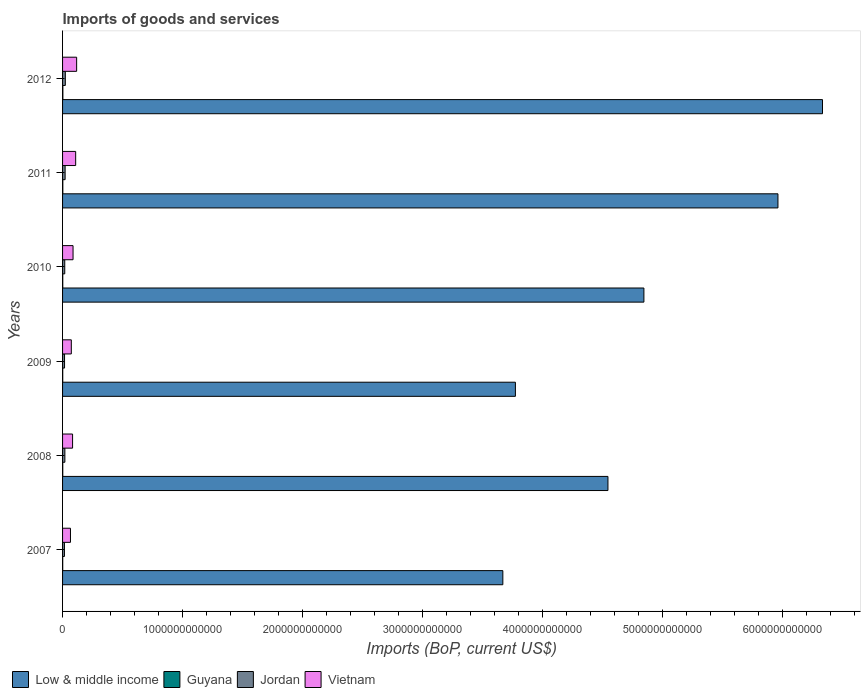How many groups of bars are there?
Your answer should be compact. 6. Are the number of bars per tick equal to the number of legend labels?
Provide a succinct answer. Yes. What is the label of the 3rd group of bars from the top?
Offer a very short reply. 2010. In how many cases, is the number of bars for a given year not equal to the number of legend labels?
Provide a succinct answer. 0. What is the amount spent on imports in Low & middle income in 2012?
Your answer should be compact. 6.33e+12. Across all years, what is the maximum amount spent on imports in Guyana?
Your answer should be compact. 2.52e+09. Across all years, what is the minimum amount spent on imports in Vietnam?
Provide a short and direct response. 6.58e+1. In which year was the amount spent on imports in Jordan maximum?
Provide a succinct answer. 2012. In which year was the amount spent on imports in Vietnam minimum?
Your answer should be very brief. 2007. What is the total amount spent on imports in Vietnam in the graph?
Keep it short and to the point. 5.36e+11. What is the difference between the amount spent on imports in Vietnam in 2008 and that in 2012?
Your response must be concise. -3.38e+1. What is the difference between the amount spent on imports in Jordan in 2010 and the amount spent on imports in Guyana in 2012?
Your answer should be very brief. 1.57e+1. What is the average amount spent on imports in Jordan per year?
Provide a short and direct response. 1.90e+1. In the year 2010, what is the difference between the amount spent on imports in Low & middle income and amount spent on imports in Vietnam?
Keep it short and to the point. 4.76e+12. What is the ratio of the amount spent on imports in Low & middle income in 2011 to that in 2012?
Your answer should be compact. 0.94. Is the difference between the amount spent on imports in Low & middle income in 2010 and 2012 greater than the difference between the amount spent on imports in Vietnam in 2010 and 2012?
Your response must be concise. No. What is the difference between the highest and the second highest amount spent on imports in Low & middle income?
Your answer should be compact. 3.71e+11. What is the difference between the highest and the lowest amount spent on imports in Vietnam?
Give a very brief answer. 5.14e+1. Is the sum of the amount spent on imports in Low & middle income in 2009 and 2012 greater than the maximum amount spent on imports in Vietnam across all years?
Provide a short and direct response. Yes. Is it the case that in every year, the sum of the amount spent on imports in Guyana and amount spent on imports in Low & middle income is greater than the sum of amount spent on imports in Jordan and amount spent on imports in Vietnam?
Provide a succinct answer. Yes. What does the 2nd bar from the top in 2009 represents?
Your answer should be compact. Jordan. What does the 4th bar from the bottom in 2011 represents?
Make the answer very short. Vietnam. Are all the bars in the graph horizontal?
Your answer should be very brief. Yes. How many years are there in the graph?
Ensure brevity in your answer.  6. What is the difference between two consecutive major ticks on the X-axis?
Ensure brevity in your answer.  1.00e+12. Does the graph contain any zero values?
Offer a terse response. No. Where does the legend appear in the graph?
Make the answer very short. Bottom left. How many legend labels are there?
Your response must be concise. 4. How are the legend labels stacked?
Give a very brief answer. Horizontal. What is the title of the graph?
Offer a terse response. Imports of goods and services. What is the label or title of the X-axis?
Your answer should be very brief. Imports (BoP, current US$). What is the Imports (BoP, current US$) in Low & middle income in 2007?
Provide a short and direct response. 3.67e+12. What is the Imports (BoP, current US$) in Guyana in 2007?
Provide a succinct answer. 1.26e+09. What is the Imports (BoP, current US$) of Jordan in 2007?
Your answer should be very brief. 1.57e+1. What is the Imports (BoP, current US$) of Vietnam in 2007?
Your answer should be compact. 6.58e+1. What is the Imports (BoP, current US$) of Low & middle income in 2008?
Provide a succinct answer. 4.54e+12. What is the Imports (BoP, current US$) of Guyana in 2008?
Give a very brief answer. 1.65e+09. What is the Imports (BoP, current US$) of Jordan in 2008?
Offer a terse response. 1.92e+1. What is the Imports (BoP, current US$) of Vietnam in 2008?
Keep it short and to the point. 8.34e+1. What is the Imports (BoP, current US$) of Low & middle income in 2009?
Ensure brevity in your answer.  3.77e+12. What is the Imports (BoP, current US$) of Guyana in 2009?
Provide a short and direct response. 1.45e+09. What is the Imports (BoP, current US$) in Jordan in 2009?
Offer a very short reply. 1.65e+1. What is the Imports (BoP, current US$) of Vietnam in 2009?
Keep it short and to the point. 7.29e+1. What is the Imports (BoP, current US$) of Low & middle income in 2010?
Ensure brevity in your answer.  4.84e+12. What is the Imports (BoP, current US$) in Guyana in 2010?
Your answer should be compact. 1.66e+09. What is the Imports (BoP, current US$) of Jordan in 2010?
Your answer should be very brief. 1.82e+1. What is the Imports (BoP, current US$) of Vietnam in 2010?
Your answer should be compact. 8.73e+1. What is the Imports (BoP, current US$) of Low & middle income in 2011?
Offer a terse response. 5.96e+12. What is the Imports (BoP, current US$) in Guyana in 2011?
Make the answer very short. 2.20e+09. What is the Imports (BoP, current US$) of Jordan in 2011?
Keep it short and to the point. 2.13e+1. What is the Imports (BoP, current US$) of Vietnam in 2011?
Make the answer very short. 1.09e+11. What is the Imports (BoP, current US$) in Low & middle income in 2012?
Make the answer very short. 6.33e+12. What is the Imports (BoP, current US$) of Guyana in 2012?
Make the answer very short. 2.52e+09. What is the Imports (BoP, current US$) in Jordan in 2012?
Offer a terse response. 2.30e+1. What is the Imports (BoP, current US$) in Vietnam in 2012?
Ensure brevity in your answer.  1.17e+11. Across all years, what is the maximum Imports (BoP, current US$) in Low & middle income?
Your answer should be compact. 6.33e+12. Across all years, what is the maximum Imports (BoP, current US$) in Guyana?
Provide a short and direct response. 2.52e+09. Across all years, what is the maximum Imports (BoP, current US$) of Jordan?
Provide a short and direct response. 2.30e+1. Across all years, what is the maximum Imports (BoP, current US$) in Vietnam?
Your response must be concise. 1.17e+11. Across all years, what is the minimum Imports (BoP, current US$) of Low & middle income?
Your response must be concise. 3.67e+12. Across all years, what is the minimum Imports (BoP, current US$) in Guyana?
Ensure brevity in your answer.  1.26e+09. Across all years, what is the minimum Imports (BoP, current US$) in Jordan?
Your response must be concise. 1.57e+1. Across all years, what is the minimum Imports (BoP, current US$) in Vietnam?
Your answer should be very brief. 6.58e+1. What is the total Imports (BoP, current US$) in Low & middle income in the graph?
Your response must be concise. 2.91e+13. What is the total Imports (BoP, current US$) in Guyana in the graph?
Keep it short and to the point. 1.07e+1. What is the total Imports (BoP, current US$) in Jordan in the graph?
Offer a very short reply. 1.14e+11. What is the total Imports (BoP, current US$) in Vietnam in the graph?
Provide a succinct answer. 5.36e+11. What is the difference between the Imports (BoP, current US$) of Low & middle income in 2007 and that in 2008?
Keep it short and to the point. -8.76e+11. What is the difference between the Imports (BoP, current US$) of Guyana in 2007 and that in 2008?
Offer a very short reply. -3.93e+08. What is the difference between the Imports (BoP, current US$) of Jordan in 2007 and that in 2008?
Your answer should be very brief. -3.53e+09. What is the difference between the Imports (BoP, current US$) in Vietnam in 2007 and that in 2008?
Make the answer very short. -1.76e+1. What is the difference between the Imports (BoP, current US$) of Low & middle income in 2007 and that in 2009?
Give a very brief answer. -1.05e+11. What is the difference between the Imports (BoP, current US$) of Guyana in 2007 and that in 2009?
Your response must be concise. -1.96e+08. What is the difference between the Imports (BoP, current US$) of Jordan in 2007 and that in 2009?
Your answer should be very brief. -7.58e+08. What is the difference between the Imports (BoP, current US$) in Vietnam in 2007 and that in 2009?
Your answer should be very brief. -7.11e+09. What is the difference between the Imports (BoP, current US$) of Low & middle income in 2007 and that in 2010?
Your response must be concise. -1.17e+12. What is the difference between the Imports (BoP, current US$) of Guyana in 2007 and that in 2010?
Make the answer very short. -4.02e+08. What is the difference between the Imports (BoP, current US$) of Jordan in 2007 and that in 2010?
Make the answer very short. -2.54e+09. What is the difference between the Imports (BoP, current US$) in Vietnam in 2007 and that in 2010?
Give a very brief answer. -2.15e+1. What is the difference between the Imports (BoP, current US$) in Low & middle income in 2007 and that in 2011?
Your answer should be compact. -2.29e+12. What is the difference between the Imports (BoP, current US$) in Guyana in 2007 and that in 2011?
Give a very brief answer. -9.49e+08. What is the difference between the Imports (BoP, current US$) in Jordan in 2007 and that in 2011?
Offer a very short reply. -5.60e+09. What is the difference between the Imports (BoP, current US$) of Vietnam in 2007 and that in 2011?
Make the answer very short. -4.34e+1. What is the difference between the Imports (BoP, current US$) of Low & middle income in 2007 and that in 2012?
Your response must be concise. -2.66e+12. What is the difference between the Imports (BoP, current US$) in Guyana in 2007 and that in 2012?
Your answer should be very brief. -1.27e+09. What is the difference between the Imports (BoP, current US$) in Jordan in 2007 and that in 2012?
Ensure brevity in your answer.  -7.27e+09. What is the difference between the Imports (BoP, current US$) in Vietnam in 2007 and that in 2012?
Make the answer very short. -5.14e+1. What is the difference between the Imports (BoP, current US$) in Low & middle income in 2008 and that in 2009?
Keep it short and to the point. 7.71e+11. What is the difference between the Imports (BoP, current US$) in Guyana in 2008 and that in 2009?
Your response must be concise. 1.97e+08. What is the difference between the Imports (BoP, current US$) in Jordan in 2008 and that in 2009?
Your answer should be compact. 2.77e+09. What is the difference between the Imports (BoP, current US$) in Vietnam in 2008 and that in 2009?
Offer a terse response. 1.05e+1. What is the difference between the Imports (BoP, current US$) of Low & middle income in 2008 and that in 2010?
Ensure brevity in your answer.  -2.99e+11. What is the difference between the Imports (BoP, current US$) of Guyana in 2008 and that in 2010?
Ensure brevity in your answer.  -8.76e+06. What is the difference between the Imports (BoP, current US$) of Jordan in 2008 and that in 2010?
Make the answer very short. 9.87e+08. What is the difference between the Imports (BoP, current US$) in Vietnam in 2008 and that in 2010?
Your answer should be compact. -3.87e+09. What is the difference between the Imports (BoP, current US$) of Low & middle income in 2008 and that in 2011?
Provide a short and direct response. -1.42e+12. What is the difference between the Imports (BoP, current US$) in Guyana in 2008 and that in 2011?
Offer a very short reply. -5.55e+08. What is the difference between the Imports (BoP, current US$) in Jordan in 2008 and that in 2011?
Provide a short and direct response. -2.07e+09. What is the difference between the Imports (BoP, current US$) in Vietnam in 2008 and that in 2011?
Provide a short and direct response. -2.58e+1. What is the difference between the Imports (BoP, current US$) of Low & middle income in 2008 and that in 2012?
Give a very brief answer. -1.79e+12. What is the difference between the Imports (BoP, current US$) in Guyana in 2008 and that in 2012?
Keep it short and to the point. -8.74e+08. What is the difference between the Imports (BoP, current US$) in Jordan in 2008 and that in 2012?
Your answer should be compact. -3.75e+09. What is the difference between the Imports (BoP, current US$) of Vietnam in 2008 and that in 2012?
Make the answer very short. -3.38e+1. What is the difference between the Imports (BoP, current US$) in Low & middle income in 2009 and that in 2010?
Offer a terse response. -1.07e+12. What is the difference between the Imports (BoP, current US$) in Guyana in 2009 and that in 2010?
Offer a very short reply. -2.06e+08. What is the difference between the Imports (BoP, current US$) of Jordan in 2009 and that in 2010?
Offer a very short reply. -1.78e+09. What is the difference between the Imports (BoP, current US$) of Vietnam in 2009 and that in 2010?
Your response must be concise. -1.44e+1. What is the difference between the Imports (BoP, current US$) of Low & middle income in 2009 and that in 2011?
Give a very brief answer. -2.19e+12. What is the difference between the Imports (BoP, current US$) in Guyana in 2009 and that in 2011?
Make the answer very short. -7.52e+08. What is the difference between the Imports (BoP, current US$) of Jordan in 2009 and that in 2011?
Provide a succinct answer. -4.84e+09. What is the difference between the Imports (BoP, current US$) in Vietnam in 2009 and that in 2011?
Your answer should be compact. -3.63e+1. What is the difference between the Imports (BoP, current US$) in Low & middle income in 2009 and that in 2012?
Give a very brief answer. -2.56e+12. What is the difference between the Imports (BoP, current US$) of Guyana in 2009 and that in 2012?
Make the answer very short. -1.07e+09. What is the difference between the Imports (BoP, current US$) of Jordan in 2009 and that in 2012?
Your answer should be compact. -6.52e+09. What is the difference between the Imports (BoP, current US$) in Vietnam in 2009 and that in 2012?
Make the answer very short. -4.43e+1. What is the difference between the Imports (BoP, current US$) of Low & middle income in 2010 and that in 2011?
Offer a very short reply. -1.12e+12. What is the difference between the Imports (BoP, current US$) of Guyana in 2010 and that in 2011?
Give a very brief answer. -5.47e+08. What is the difference between the Imports (BoP, current US$) of Jordan in 2010 and that in 2011?
Give a very brief answer. -3.06e+09. What is the difference between the Imports (BoP, current US$) in Vietnam in 2010 and that in 2011?
Keep it short and to the point. -2.19e+1. What is the difference between the Imports (BoP, current US$) in Low & middle income in 2010 and that in 2012?
Provide a succinct answer. -1.49e+12. What is the difference between the Imports (BoP, current US$) in Guyana in 2010 and that in 2012?
Your answer should be compact. -8.66e+08. What is the difference between the Imports (BoP, current US$) of Jordan in 2010 and that in 2012?
Offer a very short reply. -4.73e+09. What is the difference between the Imports (BoP, current US$) of Vietnam in 2010 and that in 2012?
Provide a short and direct response. -2.99e+1. What is the difference between the Imports (BoP, current US$) in Low & middle income in 2011 and that in 2012?
Make the answer very short. -3.71e+11. What is the difference between the Imports (BoP, current US$) in Guyana in 2011 and that in 2012?
Give a very brief answer. -3.19e+08. What is the difference between the Imports (BoP, current US$) of Jordan in 2011 and that in 2012?
Your response must be concise. -1.67e+09. What is the difference between the Imports (BoP, current US$) in Vietnam in 2011 and that in 2012?
Your answer should be very brief. -7.99e+09. What is the difference between the Imports (BoP, current US$) in Low & middle income in 2007 and the Imports (BoP, current US$) in Guyana in 2008?
Offer a very short reply. 3.67e+12. What is the difference between the Imports (BoP, current US$) in Low & middle income in 2007 and the Imports (BoP, current US$) in Jordan in 2008?
Provide a short and direct response. 3.65e+12. What is the difference between the Imports (BoP, current US$) of Low & middle income in 2007 and the Imports (BoP, current US$) of Vietnam in 2008?
Ensure brevity in your answer.  3.58e+12. What is the difference between the Imports (BoP, current US$) in Guyana in 2007 and the Imports (BoP, current US$) in Jordan in 2008?
Your response must be concise. -1.80e+1. What is the difference between the Imports (BoP, current US$) of Guyana in 2007 and the Imports (BoP, current US$) of Vietnam in 2008?
Your answer should be compact. -8.22e+1. What is the difference between the Imports (BoP, current US$) in Jordan in 2007 and the Imports (BoP, current US$) in Vietnam in 2008?
Offer a very short reply. -6.77e+1. What is the difference between the Imports (BoP, current US$) of Low & middle income in 2007 and the Imports (BoP, current US$) of Guyana in 2009?
Your response must be concise. 3.67e+12. What is the difference between the Imports (BoP, current US$) of Low & middle income in 2007 and the Imports (BoP, current US$) of Jordan in 2009?
Provide a succinct answer. 3.65e+12. What is the difference between the Imports (BoP, current US$) in Low & middle income in 2007 and the Imports (BoP, current US$) in Vietnam in 2009?
Keep it short and to the point. 3.59e+12. What is the difference between the Imports (BoP, current US$) of Guyana in 2007 and the Imports (BoP, current US$) of Jordan in 2009?
Make the answer very short. -1.52e+1. What is the difference between the Imports (BoP, current US$) in Guyana in 2007 and the Imports (BoP, current US$) in Vietnam in 2009?
Your answer should be compact. -7.16e+1. What is the difference between the Imports (BoP, current US$) of Jordan in 2007 and the Imports (BoP, current US$) of Vietnam in 2009?
Provide a short and direct response. -5.72e+1. What is the difference between the Imports (BoP, current US$) in Low & middle income in 2007 and the Imports (BoP, current US$) in Guyana in 2010?
Your response must be concise. 3.67e+12. What is the difference between the Imports (BoP, current US$) in Low & middle income in 2007 and the Imports (BoP, current US$) in Jordan in 2010?
Your answer should be compact. 3.65e+12. What is the difference between the Imports (BoP, current US$) of Low & middle income in 2007 and the Imports (BoP, current US$) of Vietnam in 2010?
Your response must be concise. 3.58e+12. What is the difference between the Imports (BoP, current US$) of Guyana in 2007 and the Imports (BoP, current US$) of Jordan in 2010?
Your answer should be very brief. -1.70e+1. What is the difference between the Imports (BoP, current US$) of Guyana in 2007 and the Imports (BoP, current US$) of Vietnam in 2010?
Give a very brief answer. -8.60e+1. What is the difference between the Imports (BoP, current US$) in Jordan in 2007 and the Imports (BoP, current US$) in Vietnam in 2010?
Make the answer very short. -7.16e+1. What is the difference between the Imports (BoP, current US$) of Low & middle income in 2007 and the Imports (BoP, current US$) of Guyana in 2011?
Ensure brevity in your answer.  3.67e+12. What is the difference between the Imports (BoP, current US$) in Low & middle income in 2007 and the Imports (BoP, current US$) in Jordan in 2011?
Provide a short and direct response. 3.65e+12. What is the difference between the Imports (BoP, current US$) in Low & middle income in 2007 and the Imports (BoP, current US$) in Vietnam in 2011?
Provide a succinct answer. 3.56e+12. What is the difference between the Imports (BoP, current US$) in Guyana in 2007 and the Imports (BoP, current US$) in Jordan in 2011?
Provide a succinct answer. -2.00e+1. What is the difference between the Imports (BoP, current US$) in Guyana in 2007 and the Imports (BoP, current US$) in Vietnam in 2011?
Ensure brevity in your answer.  -1.08e+11. What is the difference between the Imports (BoP, current US$) of Jordan in 2007 and the Imports (BoP, current US$) of Vietnam in 2011?
Give a very brief answer. -9.35e+1. What is the difference between the Imports (BoP, current US$) of Low & middle income in 2007 and the Imports (BoP, current US$) of Guyana in 2012?
Your answer should be compact. 3.66e+12. What is the difference between the Imports (BoP, current US$) in Low & middle income in 2007 and the Imports (BoP, current US$) in Jordan in 2012?
Your answer should be compact. 3.64e+12. What is the difference between the Imports (BoP, current US$) in Low & middle income in 2007 and the Imports (BoP, current US$) in Vietnam in 2012?
Your answer should be compact. 3.55e+12. What is the difference between the Imports (BoP, current US$) in Guyana in 2007 and the Imports (BoP, current US$) in Jordan in 2012?
Offer a very short reply. -2.17e+1. What is the difference between the Imports (BoP, current US$) of Guyana in 2007 and the Imports (BoP, current US$) of Vietnam in 2012?
Your response must be concise. -1.16e+11. What is the difference between the Imports (BoP, current US$) in Jordan in 2007 and the Imports (BoP, current US$) in Vietnam in 2012?
Offer a terse response. -1.02e+11. What is the difference between the Imports (BoP, current US$) of Low & middle income in 2008 and the Imports (BoP, current US$) of Guyana in 2009?
Provide a short and direct response. 4.54e+12. What is the difference between the Imports (BoP, current US$) in Low & middle income in 2008 and the Imports (BoP, current US$) in Jordan in 2009?
Offer a terse response. 4.53e+12. What is the difference between the Imports (BoP, current US$) of Low & middle income in 2008 and the Imports (BoP, current US$) of Vietnam in 2009?
Your answer should be very brief. 4.47e+12. What is the difference between the Imports (BoP, current US$) of Guyana in 2008 and the Imports (BoP, current US$) of Jordan in 2009?
Offer a very short reply. -1.48e+1. What is the difference between the Imports (BoP, current US$) in Guyana in 2008 and the Imports (BoP, current US$) in Vietnam in 2009?
Offer a terse response. -7.12e+1. What is the difference between the Imports (BoP, current US$) of Jordan in 2008 and the Imports (BoP, current US$) of Vietnam in 2009?
Your response must be concise. -5.37e+1. What is the difference between the Imports (BoP, current US$) in Low & middle income in 2008 and the Imports (BoP, current US$) in Guyana in 2010?
Your response must be concise. 4.54e+12. What is the difference between the Imports (BoP, current US$) in Low & middle income in 2008 and the Imports (BoP, current US$) in Jordan in 2010?
Ensure brevity in your answer.  4.52e+12. What is the difference between the Imports (BoP, current US$) in Low & middle income in 2008 and the Imports (BoP, current US$) in Vietnam in 2010?
Offer a very short reply. 4.46e+12. What is the difference between the Imports (BoP, current US$) in Guyana in 2008 and the Imports (BoP, current US$) in Jordan in 2010?
Ensure brevity in your answer.  -1.66e+1. What is the difference between the Imports (BoP, current US$) in Guyana in 2008 and the Imports (BoP, current US$) in Vietnam in 2010?
Your response must be concise. -8.56e+1. What is the difference between the Imports (BoP, current US$) in Jordan in 2008 and the Imports (BoP, current US$) in Vietnam in 2010?
Give a very brief answer. -6.81e+1. What is the difference between the Imports (BoP, current US$) in Low & middle income in 2008 and the Imports (BoP, current US$) in Guyana in 2011?
Offer a terse response. 4.54e+12. What is the difference between the Imports (BoP, current US$) of Low & middle income in 2008 and the Imports (BoP, current US$) of Jordan in 2011?
Provide a succinct answer. 4.52e+12. What is the difference between the Imports (BoP, current US$) in Low & middle income in 2008 and the Imports (BoP, current US$) in Vietnam in 2011?
Your answer should be very brief. 4.43e+12. What is the difference between the Imports (BoP, current US$) in Guyana in 2008 and the Imports (BoP, current US$) in Jordan in 2011?
Offer a very short reply. -1.97e+1. What is the difference between the Imports (BoP, current US$) of Guyana in 2008 and the Imports (BoP, current US$) of Vietnam in 2011?
Offer a terse response. -1.08e+11. What is the difference between the Imports (BoP, current US$) of Jordan in 2008 and the Imports (BoP, current US$) of Vietnam in 2011?
Make the answer very short. -9.00e+1. What is the difference between the Imports (BoP, current US$) of Low & middle income in 2008 and the Imports (BoP, current US$) of Guyana in 2012?
Your answer should be very brief. 4.54e+12. What is the difference between the Imports (BoP, current US$) in Low & middle income in 2008 and the Imports (BoP, current US$) in Jordan in 2012?
Keep it short and to the point. 4.52e+12. What is the difference between the Imports (BoP, current US$) in Low & middle income in 2008 and the Imports (BoP, current US$) in Vietnam in 2012?
Provide a short and direct response. 4.43e+12. What is the difference between the Imports (BoP, current US$) in Guyana in 2008 and the Imports (BoP, current US$) in Jordan in 2012?
Provide a succinct answer. -2.13e+1. What is the difference between the Imports (BoP, current US$) of Guyana in 2008 and the Imports (BoP, current US$) of Vietnam in 2012?
Provide a short and direct response. -1.16e+11. What is the difference between the Imports (BoP, current US$) of Jordan in 2008 and the Imports (BoP, current US$) of Vietnam in 2012?
Offer a terse response. -9.80e+1. What is the difference between the Imports (BoP, current US$) in Low & middle income in 2009 and the Imports (BoP, current US$) in Guyana in 2010?
Your response must be concise. 3.77e+12. What is the difference between the Imports (BoP, current US$) of Low & middle income in 2009 and the Imports (BoP, current US$) of Jordan in 2010?
Give a very brief answer. 3.75e+12. What is the difference between the Imports (BoP, current US$) in Low & middle income in 2009 and the Imports (BoP, current US$) in Vietnam in 2010?
Provide a short and direct response. 3.68e+12. What is the difference between the Imports (BoP, current US$) in Guyana in 2009 and the Imports (BoP, current US$) in Jordan in 2010?
Provide a short and direct response. -1.68e+1. What is the difference between the Imports (BoP, current US$) of Guyana in 2009 and the Imports (BoP, current US$) of Vietnam in 2010?
Offer a very short reply. -8.58e+1. What is the difference between the Imports (BoP, current US$) in Jordan in 2009 and the Imports (BoP, current US$) in Vietnam in 2010?
Offer a very short reply. -7.08e+1. What is the difference between the Imports (BoP, current US$) of Low & middle income in 2009 and the Imports (BoP, current US$) of Guyana in 2011?
Your response must be concise. 3.77e+12. What is the difference between the Imports (BoP, current US$) of Low & middle income in 2009 and the Imports (BoP, current US$) of Jordan in 2011?
Offer a terse response. 3.75e+12. What is the difference between the Imports (BoP, current US$) in Low & middle income in 2009 and the Imports (BoP, current US$) in Vietnam in 2011?
Provide a short and direct response. 3.66e+12. What is the difference between the Imports (BoP, current US$) of Guyana in 2009 and the Imports (BoP, current US$) of Jordan in 2011?
Your answer should be compact. -1.98e+1. What is the difference between the Imports (BoP, current US$) in Guyana in 2009 and the Imports (BoP, current US$) in Vietnam in 2011?
Give a very brief answer. -1.08e+11. What is the difference between the Imports (BoP, current US$) in Jordan in 2009 and the Imports (BoP, current US$) in Vietnam in 2011?
Offer a very short reply. -9.28e+1. What is the difference between the Imports (BoP, current US$) in Low & middle income in 2009 and the Imports (BoP, current US$) in Guyana in 2012?
Offer a very short reply. 3.77e+12. What is the difference between the Imports (BoP, current US$) of Low & middle income in 2009 and the Imports (BoP, current US$) of Jordan in 2012?
Your answer should be very brief. 3.75e+12. What is the difference between the Imports (BoP, current US$) in Low & middle income in 2009 and the Imports (BoP, current US$) in Vietnam in 2012?
Offer a very short reply. 3.65e+12. What is the difference between the Imports (BoP, current US$) in Guyana in 2009 and the Imports (BoP, current US$) in Jordan in 2012?
Your answer should be compact. -2.15e+1. What is the difference between the Imports (BoP, current US$) of Guyana in 2009 and the Imports (BoP, current US$) of Vietnam in 2012?
Offer a very short reply. -1.16e+11. What is the difference between the Imports (BoP, current US$) in Jordan in 2009 and the Imports (BoP, current US$) in Vietnam in 2012?
Provide a short and direct response. -1.01e+11. What is the difference between the Imports (BoP, current US$) of Low & middle income in 2010 and the Imports (BoP, current US$) of Guyana in 2011?
Provide a succinct answer. 4.84e+12. What is the difference between the Imports (BoP, current US$) in Low & middle income in 2010 and the Imports (BoP, current US$) in Jordan in 2011?
Provide a succinct answer. 4.82e+12. What is the difference between the Imports (BoP, current US$) of Low & middle income in 2010 and the Imports (BoP, current US$) of Vietnam in 2011?
Ensure brevity in your answer.  4.73e+12. What is the difference between the Imports (BoP, current US$) in Guyana in 2010 and the Imports (BoP, current US$) in Jordan in 2011?
Keep it short and to the point. -1.96e+1. What is the difference between the Imports (BoP, current US$) in Guyana in 2010 and the Imports (BoP, current US$) in Vietnam in 2011?
Ensure brevity in your answer.  -1.08e+11. What is the difference between the Imports (BoP, current US$) in Jordan in 2010 and the Imports (BoP, current US$) in Vietnam in 2011?
Your answer should be very brief. -9.10e+1. What is the difference between the Imports (BoP, current US$) in Low & middle income in 2010 and the Imports (BoP, current US$) in Guyana in 2012?
Provide a short and direct response. 4.84e+12. What is the difference between the Imports (BoP, current US$) of Low & middle income in 2010 and the Imports (BoP, current US$) of Jordan in 2012?
Your answer should be very brief. 4.82e+12. What is the difference between the Imports (BoP, current US$) in Low & middle income in 2010 and the Imports (BoP, current US$) in Vietnam in 2012?
Make the answer very short. 4.73e+12. What is the difference between the Imports (BoP, current US$) of Guyana in 2010 and the Imports (BoP, current US$) of Jordan in 2012?
Provide a short and direct response. -2.13e+1. What is the difference between the Imports (BoP, current US$) of Guyana in 2010 and the Imports (BoP, current US$) of Vietnam in 2012?
Offer a terse response. -1.16e+11. What is the difference between the Imports (BoP, current US$) of Jordan in 2010 and the Imports (BoP, current US$) of Vietnam in 2012?
Provide a succinct answer. -9.90e+1. What is the difference between the Imports (BoP, current US$) in Low & middle income in 2011 and the Imports (BoP, current US$) in Guyana in 2012?
Give a very brief answer. 5.96e+12. What is the difference between the Imports (BoP, current US$) of Low & middle income in 2011 and the Imports (BoP, current US$) of Jordan in 2012?
Make the answer very short. 5.94e+12. What is the difference between the Imports (BoP, current US$) in Low & middle income in 2011 and the Imports (BoP, current US$) in Vietnam in 2012?
Your answer should be very brief. 5.84e+12. What is the difference between the Imports (BoP, current US$) in Guyana in 2011 and the Imports (BoP, current US$) in Jordan in 2012?
Your response must be concise. -2.08e+1. What is the difference between the Imports (BoP, current US$) of Guyana in 2011 and the Imports (BoP, current US$) of Vietnam in 2012?
Make the answer very short. -1.15e+11. What is the difference between the Imports (BoP, current US$) of Jordan in 2011 and the Imports (BoP, current US$) of Vietnam in 2012?
Keep it short and to the point. -9.59e+1. What is the average Imports (BoP, current US$) of Low & middle income per year?
Keep it short and to the point. 4.85e+12. What is the average Imports (BoP, current US$) of Guyana per year?
Your answer should be compact. 1.79e+09. What is the average Imports (BoP, current US$) of Jordan per year?
Make the answer very short. 1.90e+1. What is the average Imports (BoP, current US$) of Vietnam per year?
Your answer should be compact. 8.93e+1. In the year 2007, what is the difference between the Imports (BoP, current US$) of Low & middle income and Imports (BoP, current US$) of Guyana?
Ensure brevity in your answer.  3.67e+12. In the year 2007, what is the difference between the Imports (BoP, current US$) in Low & middle income and Imports (BoP, current US$) in Jordan?
Offer a very short reply. 3.65e+12. In the year 2007, what is the difference between the Imports (BoP, current US$) of Low & middle income and Imports (BoP, current US$) of Vietnam?
Give a very brief answer. 3.60e+12. In the year 2007, what is the difference between the Imports (BoP, current US$) in Guyana and Imports (BoP, current US$) in Jordan?
Your answer should be very brief. -1.44e+1. In the year 2007, what is the difference between the Imports (BoP, current US$) of Guyana and Imports (BoP, current US$) of Vietnam?
Provide a succinct answer. -6.45e+1. In the year 2007, what is the difference between the Imports (BoP, current US$) in Jordan and Imports (BoP, current US$) in Vietnam?
Ensure brevity in your answer.  -5.01e+1. In the year 2008, what is the difference between the Imports (BoP, current US$) of Low & middle income and Imports (BoP, current US$) of Guyana?
Provide a succinct answer. 4.54e+12. In the year 2008, what is the difference between the Imports (BoP, current US$) in Low & middle income and Imports (BoP, current US$) in Jordan?
Your answer should be compact. 4.52e+12. In the year 2008, what is the difference between the Imports (BoP, current US$) in Low & middle income and Imports (BoP, current US$) in Vietnam?
Make the answer very short. 4.46e+12. In the year 2008, what is the difference between the Imports (BoP, current US$) in Guyana and Imports (BoP, current US$) in Jordan?
Your response must be concise. -1.76e+1. In the year 2008, what is the difference between the Imports (BoP, current US$) in Guyana and Imports (BoP, current US$) in Vietnam?
Make the answer very short. -8.18e+1. In the year 2008, what is the difference between the Imports (BoP, current US$) of Jordan and Imports (BoP, current US$) of Vietnam?
Give a very brief answer. -6.42e+1. In the year 2009, what is the difference between the Imports (BoP, current US$) in Low & middle income and Imports (BoP, current US$) in Guyana?
Offer a terse response. 3.77e+12. In the year 2009, what is the difference between the Imports (BoP, current US$) in Low & middle income and Imports (BoP, current US$) in Jordan?
Give a very brief answer. 3.76e+12. In the year 2009, what is the difference between the Imports (BoP, current US$) of Low & middle income and Imports (BoP, current US$) of Vietnam?
Keep it short and to the point. 3.70e+12. In the year 2009, what is the difference between the Imports (BoP, current US$) in Guyana and Imports (BoP, current US$) in Jordan?
Keep it short and to the point. -1.50e+1. In the year 2009, what is the difference between the Imports (BoP, current US$) of Guyana and Imports (BoP, current US$) of Vietnam?
Provide a succinct answer. -7.14e+1. In the year 2009, what is the difference between the Imports (BoP, current US$) in Jordan and Imports (BoP, current US$) in Vietnam?
Provide a succinct answer. -5.64e+1. In the year 2010, what is the difference between the Imports (BoP, current US$) of Low & middle income and Imports (BoP, current US$) of Guyana?
Offer a very short reply. 4.84e+12. In the year 2010, what is the difference between the Imports (BoP, current US$) of Low & middle income and Imports (BoP, current US$) of Jordan?
Your answer should be compact. 4.82e+12. In the year 2010, what is the difference between the Imports (BoP, current US$) in Low & middle income and Imports (BoP, current US$) in Vietnam?
Your answer should be very brief. 4.76e+12. In the year 2010, what is the difference between the Imports (BoP, current US$) of Guyana and Imports (BoP, current US$) of Jordan?
Ensure brevity in your answer.  -1.66e+1. In the year 2010, what is the difference between the Imports (BoP, current US$) of Guyana and Imports (BoP, current US$) of Vietnam?
Offer a very short reply. -8.56e+1. In the year 2010, what is the difference between the Imports (BoP, current US$) of Jordan and Imports (BoP, current US$) of Vietnam?
Your answer should be very brief. -6.91e+1. In the year 2011, what is the difference between the Imports (BoP, current US$) in Low & middle income and Imports (BoP, current US$) in Guyana?
Provide a short and direct response. 5.96e+12. In the year 2011, what is the difference between the Imports (BoP, current US$) of Low & middle income and Imports (BoP, current US$) of Jordan?
Provide a short and direct response. 5.94e+12. In the year 2011, what is the difference between the Imports (BoP, current US$) of Low & middle income and Imports (BoP, current US$) of Vietnam?
Your response must be concise. 5.85e+12. In the year 2011, what is the difference between the Imports (BoP, current US$) of Guyana and Imports (BoP, current US$) of Jordan?
Your answer should be very brief. -1.91e+1. In the year 2011, what is the difference between the Imports (BoP, current US$) of Guyana and Imports (BoP, current US$) of Vietnam?
Your response must be concise. -1.07e+11. In the year 2011, what is the difference between the Imports (BoP, current US$) in Jordan and Imports (BoP, current US$) in Vietnam?
Your response must be concise. -8.79e+1. In the year 2012, what is the difference between the Imports (BoP, current US$) of Low & middle income and Imports (BoP, current US$) of Guyana?
Offer a terse response. 6.33e+12. In the year 2012, what is the difference between the Imports (BoP, current US$) of Low & middle income and Imports (BoP, current US$) of Jordan?
Your answer should be very brief. 6.31e+12. In the year 2012, what is the difference between the Imports (BoP, current US$) in Low & middle income and Imports (BoP, current US$) in Vietnam?
Give a very brief answer. 6.21e+12. In the year 2012, what is the difference between the Imports (BoP, current US$) of Guyana and Imports (BoP, current US$) of Jordan?
Make the answer very short. -2.05e+1. In the year 2012, what is the difference between the Imports (BoP, current US$) in Guyana and Imports (BoP, current US$) in Vietnam?
Offer a very short reply. -1.15e+11. In the year 2012, what is the difference between the Imports (BoP, current US$) in Jordan and Imports (BoP, current US$) in Vietnam?
Offer a terse response. -9.42e+1. What is the ratio of the Imports (BoP, current US$) of Low & middle income in 2007 to that in 2008?
Provide a succinct answer. 0.81. What is the ratio of the Imports (BoP, current US$) of Guyana in 2007 to that in 2008?
Keep it short and to the point. 0.76. What is the ratio of the Imports (BoP, current US$) in Jordan in 2007 to that in 2008?
Keep it short and to the point. 0.82. What is the ratio of the Imports (BoP, current US$) in Vietnam in 2007 to that in 2008?
Offer a terse response. 0.79. What is the ratio of the Imports (BoP, current US$) of Low & middle income in 2007 to that in 2009?
Your answer should be compact. 0.97. What is the ratio of the Imports (BoP, current US$) of Guyana in 2007 to that in 2009?
Keep it short and to the point. 0.86. What is the ratio of the Imports (BoP, current US$) of Jordan in 2007 to that in 2009?
Keep it short and to the point. 0.95. What is the ratio of the Imports (BoP, current US$) in Vietnam in 2007 to that in 2009?
Keep it short and to the point. 0.9. What is the ratio of the Imports (BoP, current US$) of Low & middle income in 2007 to that in 2010?
Ensure brevity in your answer.  0.76. What is the ratio of the Imports (BoP, current US$) of Guyana in 2007 to that in 2010?
Give a very brief answer. 0.76. What is the ratio of the Imports (BoP, current US$) of Jordan in 2007 to that in 2010?
Ensure brevity in your answer.  0.86. What is the ratio of the Imports (BoP, current US$) in Vietnam in 2007 to that in 2010?
Keep it short and to the point. 0.75. What is the ratio of the Imports (BoP, current US$) in Low & middle income in 2007 to that in 2011?
Provide a short and direct response. 0.62. What is the ratio of the Imports (BoP, current US$) of Guyana in 2007 to that in 2011?
Offer a very short reply. 0.57. What is the ratio of the Imports (BoP, current US$) in Jordan in 2007 to that in 2011?
Make the answer very short. 0.74. What is the ratio of the Imports (BoP, current US$) in Vietnam in 2007 to that in 2011?
Provide a succinct answer. 0.6. What is the ratio of the Imports (BoP, current US$) of Low & middle income in 2007 to that in 2012?
Keep it short and to the point. 0.58. What is the ratio of the Imports (BoP, current US$) of Guyana in 2007 to that in 2012?
Offer a terse response. 0.5. What is the ratio of the Imports (BoP, current US$) of Jordan in 2007 to that in 2012?
Your answer should be very brief. 0.68. What is the ratio of the Imports (BoP, current US$) in Vietnam in 2007 to that in 2012?
Ensure brevity in your answer.  0.56. What is the ratio of the Imports (BoP, current US$) of Low & middle income in 2008 to that in 2009?
Provide a succinct answer. 1.2. What is the ratio of the Imports (BoP, current US$) of Guyana in 2008 to that in 2009?
Provide a succinct answer. 1.14. What is the ratio of the Imports (BoP, current US$) in Jordan in 2008 to that in 2009?
Offer a terse response. 1.17. What is the ratio of the Imports (BoP, current US$) of Vietnam in 2008 to that in 2009?
Provide a short and direct response. 1.14. What is the ratio of the Imports (BoP, current US$) of Low & middle income in 2008 to that in 2010?
Your response must be concise. 0.94. What is the ratio of the Imports (BoP, current US$) of Jordan in 2008 to that in 2010?
Your answer should be compact. 1.05. What is the ratio of the Imports (BoP, current US$) of Vietnam in 2008 to that in 2010?
Offer a very short reply. 0.96. What is the ratio of the Imports (BoP, current US$) in Low & middle income in 2008 to that in 2011?
Offer a terse response. 0.76. What is the ratio of the Imports (BoP, current US$) in Guyana in 2008 to that in 2011?
Offer a terse response. 0.75. What is the ratio of the Imports (BoP, current US$) in Jordan in 2008 to that in 2011?
Keep it short and to the point. 0.9. What is the ratio of the Imports (BoP, current US$) of Vietnam in 2008 to that in 2011?
Your answer should be compact. 0.76. What is the ratio of the Imports (BoP, current US$) of Low & middle income in 2008 to that in 2012?
Ensure brevity in your answer.  0.72. What is the ratio of the Imports (BoP, current US$) of Guyana in 2008 to that in 2012?
Ensure brevity in your answer.  0.65. What is the ratio of the Imports (BoP, current US$) in Jordan in 2008 to that in 2012?
Give a very brief answer. 0.84. What is the ratio of the Imports (BoP, current US$) in Vietnam in 2008 to that in 2012?
Provide a short and direct response. 0.71. What is the ratio of the Imports (BoP, current US$) of Low & middle income in 2009 to that in 2010?
Ensure brevity in your answer.  0.78. What is the ratio of the Imports (BoP, current US$) in Guyana in 2009 to that in 2010?
Make the answer very short. 0.88. What is the ratio of the Imports (BoP, current US$) in Jordan in 2009 to that in 2010?
Your answer should be very brief. 0.9. What is the ratio of the Imports (BoP, current US$) of Vietnam in 2009 to that in 2010?
Offer a very short reply. 0.83. What is the ratio of the Imports (BoP, current US$) in Low & middle income in 2009 to that in 2011?
Your answer should be compact. 0.63. What is the ratio of the Imports (BoP, current US$) in Guyana in 2009 to that in 2011?
Provide a succinct answer. 0.66. What is the ratio of the Imports (BoP, current US$) in Jordan in 2009 to that in 2011?
Give a very brief answer. 0.77. What is the ratio of the Imports (BoP, current US$) of Vietnam in 2009 to that in 2011?
Provide a succinct answer. 0.67. What is the ratio of the Imports (BoP, current US$) of Low & middle income in 2009 to that in 2012?
Make the answer very short. 0.6. What is the ratio of the Imports (BoP, current US$) of Guyana in 2009 to that in 2012?
Offer a terse response. 0.58. What is the ratio of the Imports (BoP, current US$) in Jordan in 2009 to that in 2012?
Keep it short and to the point. 0.72. What is the ratio of the Imports (BoP, current US$) in Vietnam in 2009 to that in 2012?
Provide a succinct answer. 0.62. What is the ratio of the Imports (BoP, current US$) in Low & middle income in 2010 to that in 2011?
Keep it short and to the point. 0.81. What is the ratio of the Imports (BoP, current US$) of Guyana in 2010 to that in 2011?
Give a very brief answer. 0.75. What is the ratio of the Imports (BoP, current US$) in Jordan in 2010 to that in 2011?
Give a very brief answer. 0.86. What is the ratio of the Imports (BoP, current US$) in Vietnam in 2010 to that in 2011?
Your response must be concise. 0.8. What is the ratio of the Imports (BoP, current US$) of Low & middle income in 2010 to that in 2012?
Your response must be concise. 0.77. What is the ratio of the Imports (BoP, current US$) of Guyana in 2010 to that in 2012?
Make the answer very short. 0.66. What is the ratio of the Imports (BoP, current US$) of Jordan in 2010 to that in 2012?
Provide a short and direct response. 0.79. What is the ratio of the Imports (BoP, current US$) in Vietnam in 2010 to that in 2012?
Your response must be concise. 0.74. What is the ratio of the Imports (BoP, current US$) of Low & middle income in 2011 to that in 2012?
Provide a succinct answer. 0.94. What is the ratio of the Imports (BoP, current US$) of Guyana in 2011 to that in 2012?
Your response must be concise. 0.87. What is the ratio of the Imports (BoP, current US$) of Jordan in 2011 to that in 2012?
Make the answer very short. 0.93. What is the ratio of the Imports (BoP, current US$) of Vietnam in 2011 to that in 2012?
Ensure brevity in your answer.  0.93. What is the difference between the highest and the second highest Imports (BoP, current US$) of Low & middle income?
Provide a succinct answer. 3.71e+11. What is the difference between the highest and the second highest Imports (BoP, current US$) of Guyana?
Give a very brief answer. 3.19e+08. What is the difference between the highest and the second highest Imports (BoP, current US$) of Jordan?
Your response must be concise. 1.67e+09. What is the difference between the highest and the second highest Imports (BoP, current US$) of Vietnam?
Provide a succinct answer. 7.99e+09. What is the difference between the highest and the lowest Imports (BoP, current US$) of Low & middle income?
Provide a succinct answer. 2.66e+12. What is the difference between the highest and the lowest Imports (BoP, current US$) of Guyana?
Provide a short and direct response. 1.27e+09. What is the difference between the highest and the lowest Imports (BoP, current US$) in Jordan?
Your answer should be very brief. 7.27e+09. What is the difference between the highest and the lowest Imports (BoP, current US$) of Vietnam?
Your answer should be compact. 5.14e+1. 